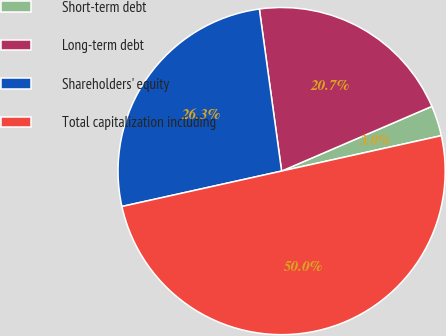<chart> <loc_0><loc_0><loc_500><loc_500><pie_chart><fcel>Short-term debt<fcel>Long-term debt<fcel>Shareholders' equity<fcel>Total capitalization including<nl><fcel>3.0%<fcel>20.7%<fcel>26.3%<fcel>50.0%<nl></chart> 